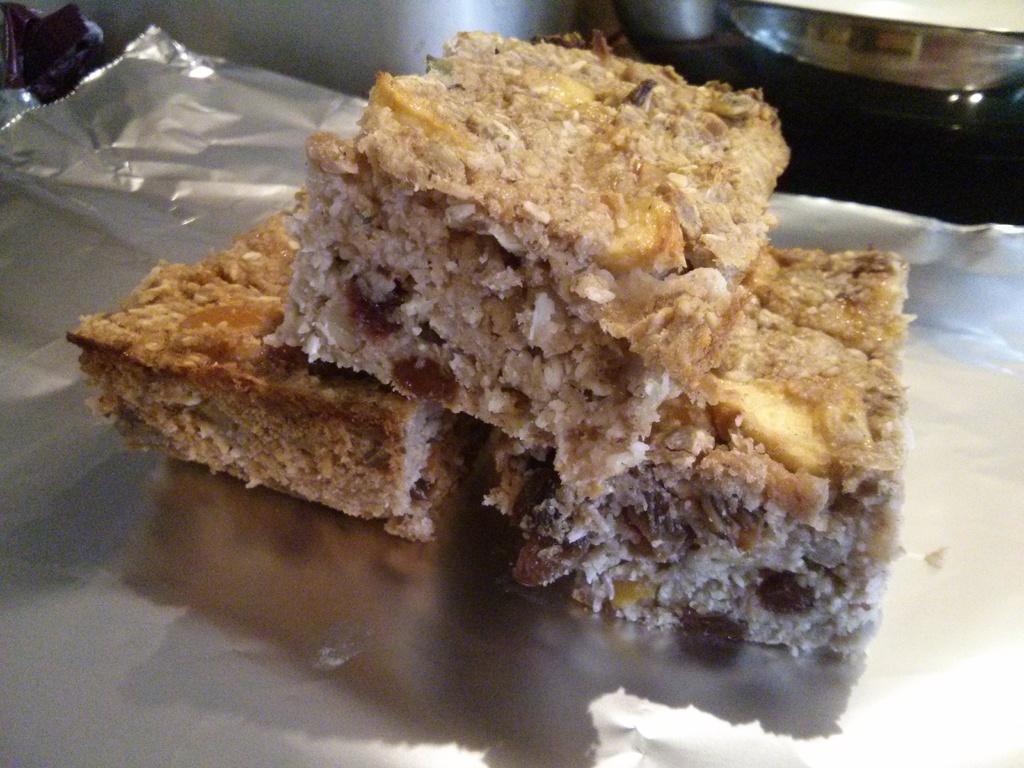Describe this image in one or two sentences. In this image, we can see a table which is in black color, on that table, we can see a silver color cover. On that cover, we can see some food item. On the right side of the table, we can see a bowl. On the left side, we can also see another cover. 